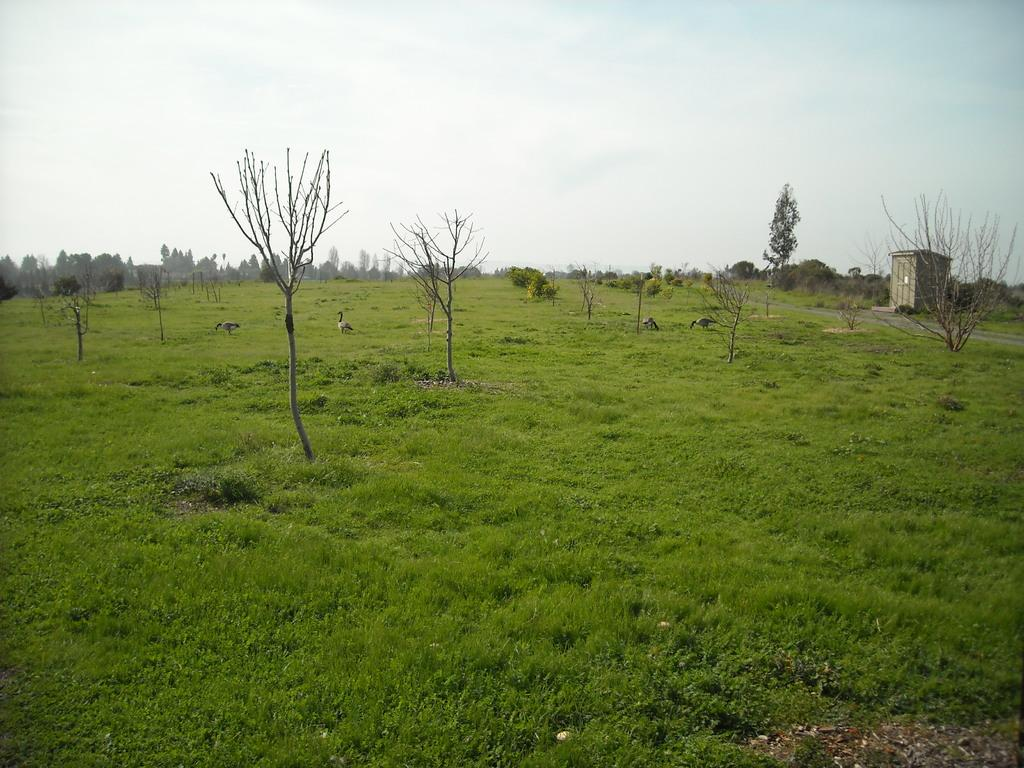What type of vegetation is present in the image? There is grass in the image. What other living beings can be seen in the image? There are animals in the image. What type of natural structures are present in the image? There are trees in the image. What type of man-made structure is present in the image? There is a small house in the image. What is visible in the background of the image? The sky is visible in the background of the image. What type of tin can be seen in the image? There is no tin present in the image. What activity are the animals engaged in within the image? The provided facts do not specify any activity that the animals are engaged in; we can only observe their presence in the image. 